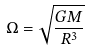Convert formula to latex. <formula><loc_0><loc_0><loc_500><loc_500>\Omega = \sqrt { \frac { G M } { R ^ { 3 } } }</formula> 